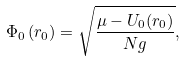<formula> <loc_0><loc_0><loc_500><loc_500>\Phi _ { 0 } \left ( { r } _ { 0 } \right ) = \sqrt { \frac { \mu - U _ { 0 } ( { r } _ { 0 } ) } { N g } } ,</formula> 